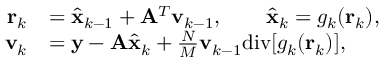Convert formula to latex. <formula><loc_0><loc_0><loc_500><loc_500>\begin{array} { r l } { r _ { k } } & { = \hat { x } _ { k - 1 } + A ^ { T } v _ { k - 1 } , \quad \hat { x } _ { k } = g _ { k } ( r _ { k } ) , } \\ { v _ { k } } & { = y - A \hat { x } _ { k } + \frac { N } { M } v _ { k - 1 } d i v [ g _ { k } ( r _ { k } ) ] , } \end{array}</formula> 